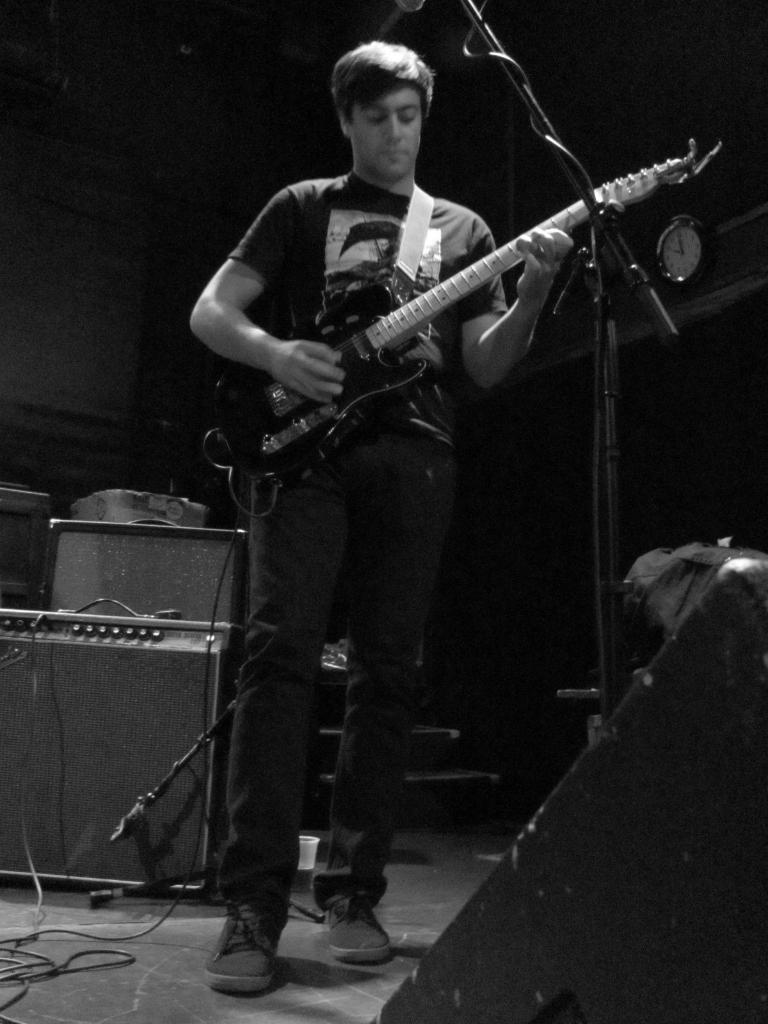Please provide a concise description of this image. in a picture a person is playing guitar with microphone in front of him 